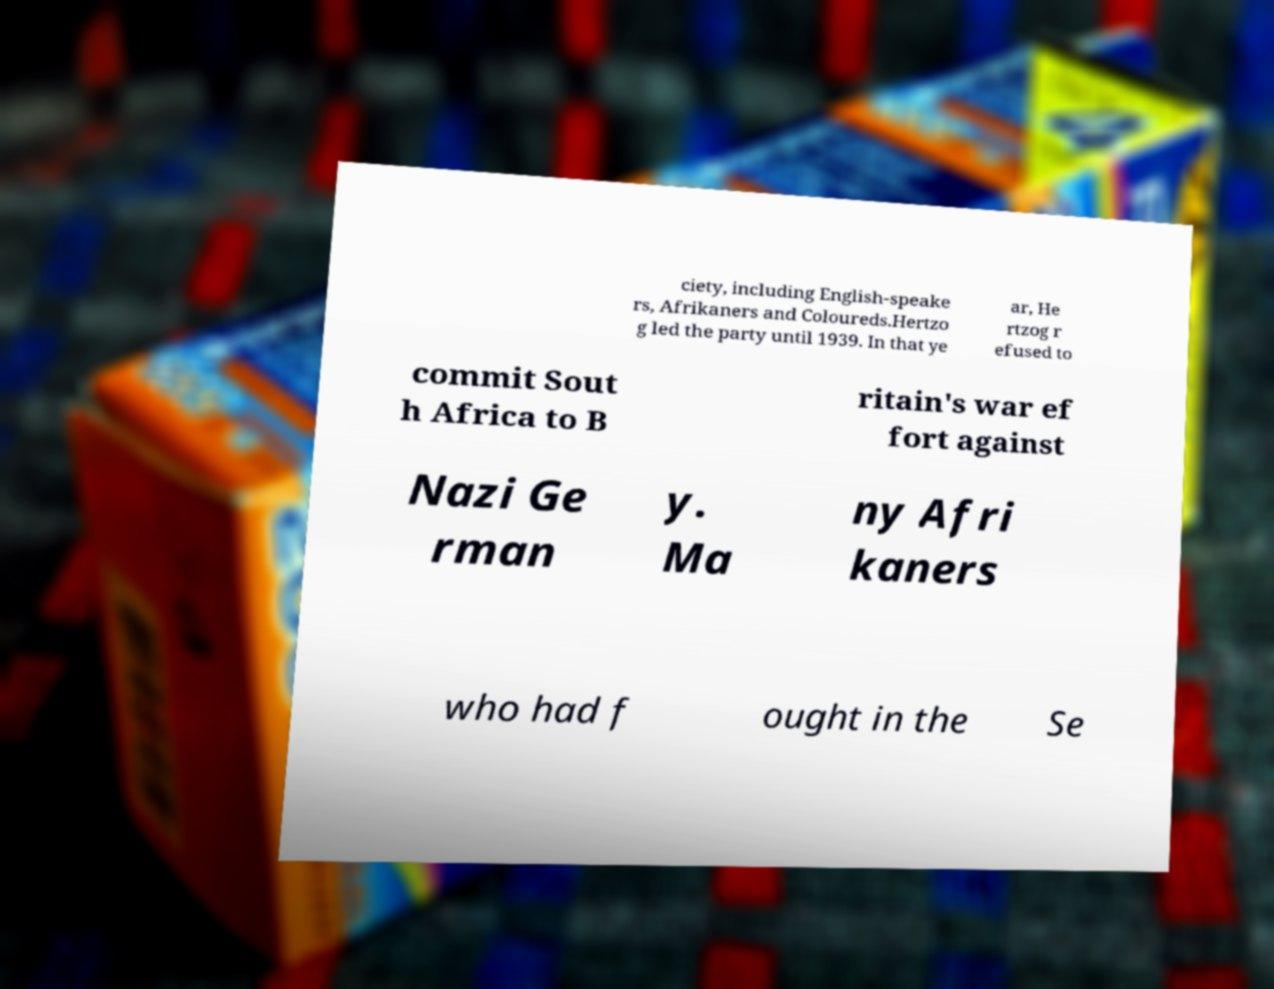Can you accurately transcribe the text from the provided image for me? ciety, including English-speake rs, Afrikaners and Coloureds.Hertzo g led the party until 1939. In that ye ar, He rtzog r efused to commit Sout h Africa to B ritain's war ef fort against Nazi Ge rman y. Ma ny Afri kaners who had f ought in the Se 